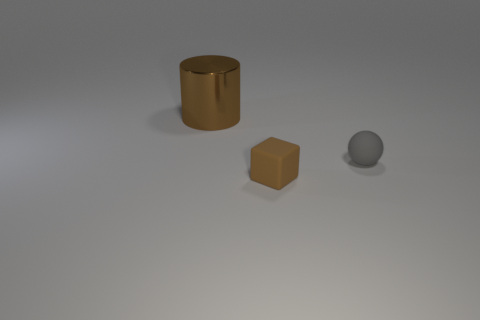What is the size of the cube that is the same color as the big shiny cylinder?
Provide a short and direct response. Small. What number of objects are brown things in front of the gray object or small rubber objects on the right side of the small brown matte thing?
Offer a very short reply. 2. Are there an equal number of small brown rubber objects behind the small brown rubber object and brown metallic things that are in front of the gray ball?
Offer a very short reply. Yes. What color is the matte thing that is to the right of the small cube?
Keep it short and to the point. Gray. Is the color of the large thing the same as the tiny matte object in front of the gray rubber object?
Your answer should be compact. Yes. Are there fewer things than rubber objects?
Provide a succinct answer. No. There is a matte object in front of the gray matte object; does it have the same color as the big shiny thing?
Offer a terse response. Yes. How many shiny cylinders are the same size as the brown shiny thing?
Offer a terse response. 0. Are there any other objects that have the same color as the big thing?
Offer a very short reply. Yes. Are the gray object and the small brown block made of the same material?
Provide a short and direct response. Yes. 